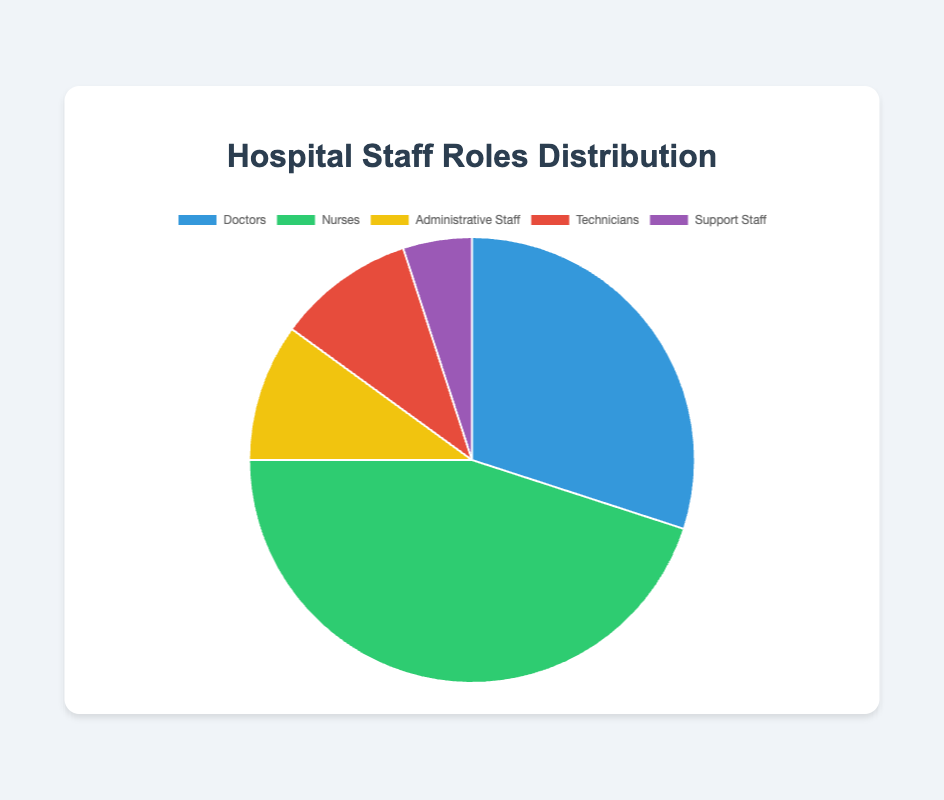What percentage of the hospital staff are nurses? The pie chart shows nurses make up 45% of the hospital staff.
Answer: 45% Which staff role is the least represented? According to the pie chart, support staff comprise the smallest segment.
Answer: Support Staff What is the combined percentage of administrative staff and technicians? Both administrative staff and technicians represent 10% each. Therefore, the combined percentage is 10% + 10% = 20%.
Answer: 20% Are there more doctors or support staff? How many more? The chart indicates there are 30% doctors and 5% support staff. The difference is 30% - 5% = 25%.
Answer: 25% Which staff role has the second highest representation? The pie chart shows nurses with 45%, which is the highest. The second highest is doctors with 30%.
Answer: Doctors What is the ratio of doctors to nurses? The percentage of doctors is 30% and nurses is 45%. The ratio is therefore 30:45 or simplified to 2:3.
Answer: 2:3 Compare the combined percentage of doctors and nurses to the combined percentage of administrative staff, technicians, and support staff. Which is higher and by how much? Doctors and nurses together are 30% + 45% = 75%. Administrative staff, technicians, and support staff together are 10% + 10% + 5% = 25%. The difference is 75% - 25% = 50%.
Answer: Combined percentage of doctors and nurses is higher by 50% What percentage of the hospital staff are neither doctors nor nurses? Excluding doctors (30%) and nurses (45%), the remaining roles sum to 100% - 30% - 45% = 25%.
Answer: 25% How much more representation do nurses have compared to administrative staff? Nurses have 45%, while administrative staff have 10%. The difference is 45% - 10% = 35%.
Answer: 35% If the hospital hired 5% more support staff, what would be the new percentage of support staff? Currently, support staff are at 5%. Increasing by 5% will make it 5% + 5% = 10%.
Answer: 10% 